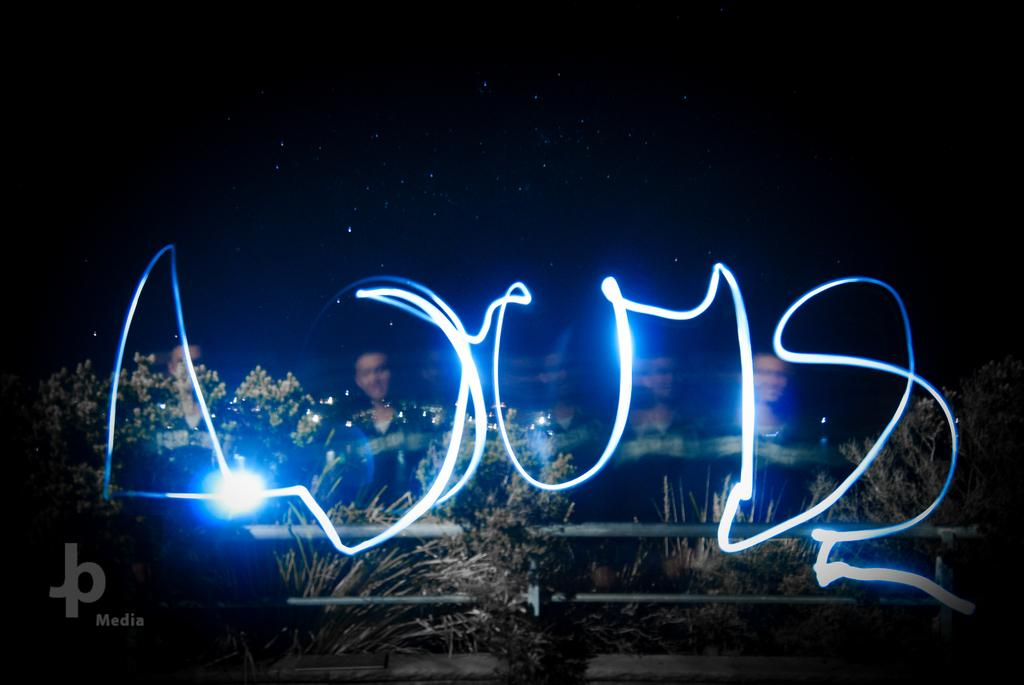What are the people in the image wearing? The people in the image are wearing clothes. Can you describe the light in the image? There is a light in the image. What is the watermark in the image? There is a watermark in the image. What type of vegetation is present in the image? There is a plant in the image. What is the pole used for in the image? The pole's purpose is not clear from the image, but it is present. What is visible in the sky in the image? The sky is visible in the image, and stars are visible in the sky. What type of egg is being used as a ball in the image? There is no egg or ball present in the image. 